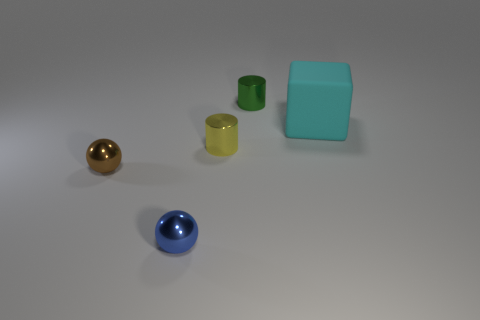There is a large block; are there any cyan cubes in front of it?
Make the answer very short. No. What material is the other tiny thing that is the same shape as the tiny blue object?
Your response must be concise. Metal. Are there any other things that are made of the same material as the big thing?
Your answer should be very brief. No. What number of other things are the same shape as the rubber object?
Give a very brief answer. 0. What number of yellow cylinders are in front of the shiny sphere on the right side of the tiny ball that is left of the blue metal ball?
Provide a succinct answer. 0. What number of blue metal objects have the same shape as the brown object?
Your answer should be very brief. 1. There is a shiny thing behind the rubber object; is it the same color as the big cube?
Your response must be concise. No. What is the shape of the tiny thing in front of the ball that is on the left side of the metallic ball that is in front of the tiny brown metallic sphere?
Your response must be concise. Sphere. There is a yellow thing; is its size the same as the metallic thing behind the large cyan thing?
Provide a short and direct response. Yes. Is there another cyan block of the same size as the cube?
Provide a short and direct response. No. 